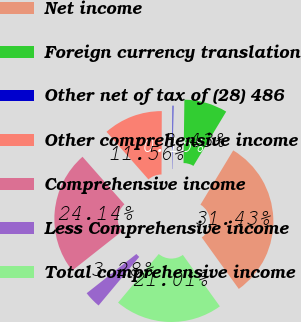<chart> <loc_0><loc_0><loc_500><loc_500><pie_chart><fcel>Net income<fcel>Foreign currency translation<fcel>Other net of tax of (28) 486<fcel>Other comprehensive income<fcel>Comprehensive income<fcel>Less Comprehensive income<fcel>Total comprehensive income<nl><fcel>31.43%<fcel>8.43%<fcel>0.15%<fcel>11.56%<fcel>24.14%<fcel>3.28%<fcel>21.01%<nl></chart> 